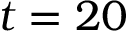<formula> <loc_0><loc_0><loc_500><loc_500>t = 2 0</formula> 